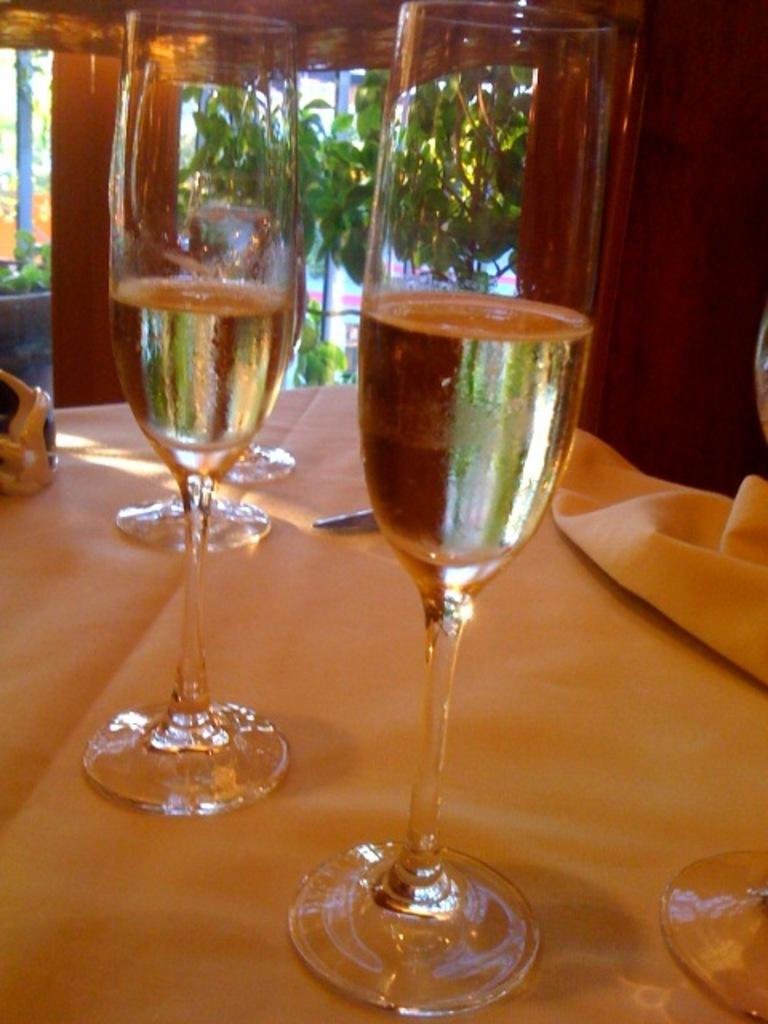What type of furniture is present in the image? There is a table in the image. What can be seen in the background of the image? There are trees in the background of the image. What is covering the table in the image? There is a white cloth on the table. What objects are placed on the table in the image? There are glasses on the table. What type of trail can be seen leading to the table in the image? There is no trail visible in the image; it only shows a table with a white cloth and glasses, as well as trees in the background. 